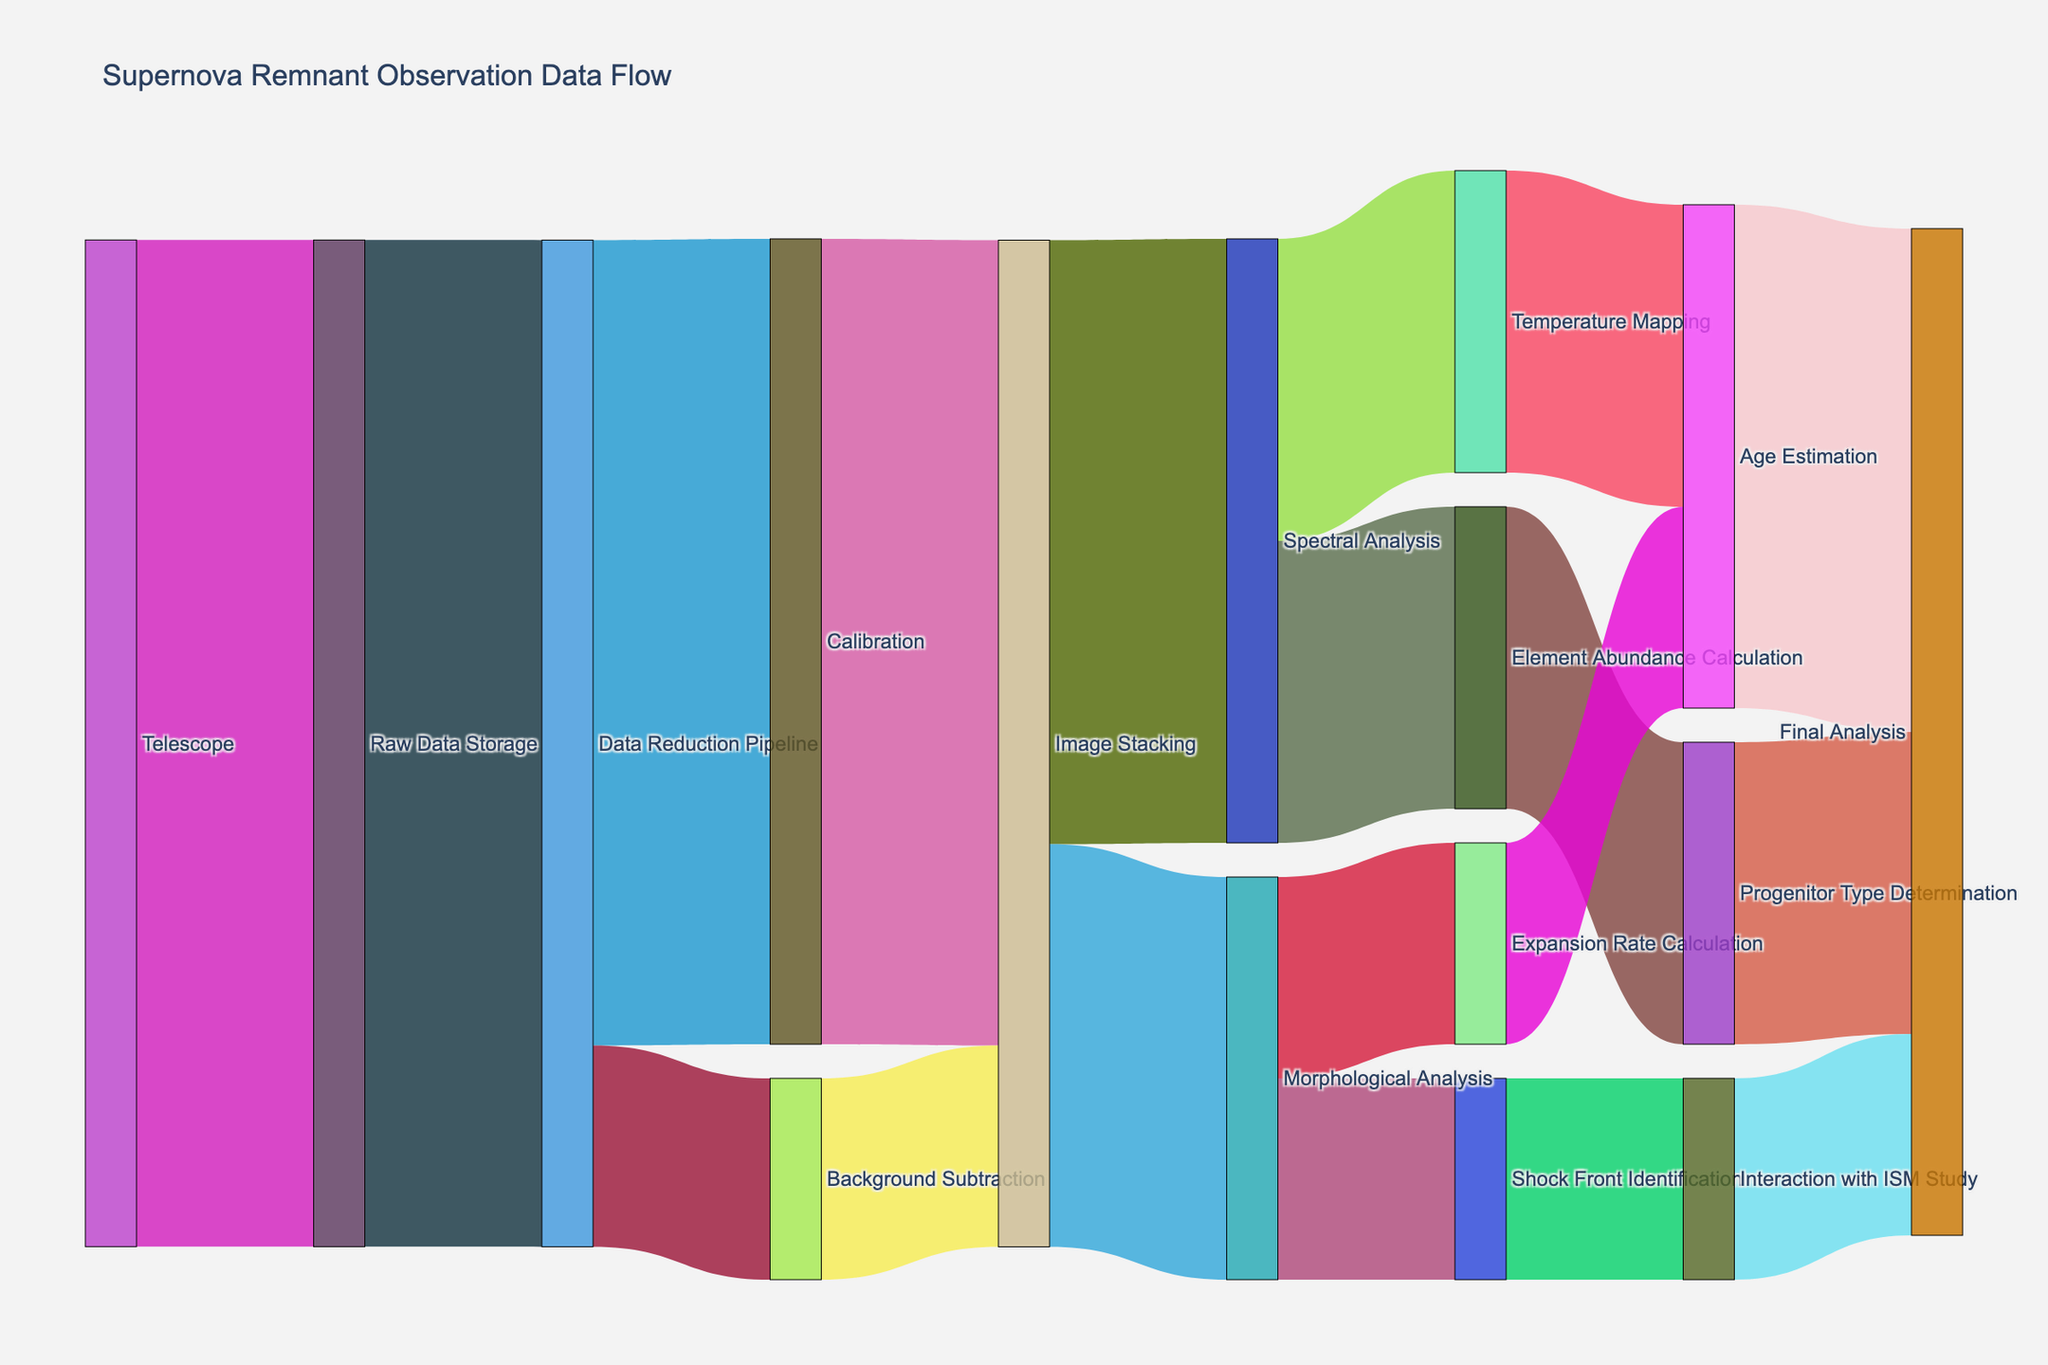Which node has the highest value coming directly from the Telescope? The diagram shows the flow of data from the Telescope node, and the node with the thickest link or highest value connected to it is Raw Data Storage, which receives 100 units of data.
Answer: Raw Data Storage What is the total value of data processed by the Data Reduction Pipeline? The Data Reduction Pipeline node sends data to Calibration (80 units) and Background Subtraction (20 units). Adding these values gives 100 units.
Answer: 100 Compare the value of data flowing into Spectral Analysis and Morphological Analysis from Image Stacking. Which one has a higher value? The Image Stacking node sends 60 units to Spectral Analysis and 40 units to Morphological Analysis. 60 units is higher than 40 units.
Answer: Spectral Analysis How much data is ultimately processed by Final Analysis? Final Analysis receives data from Progenitor Type Determination (30 units), Age Estimation (50 units), and Interaction with ISM Study (20 units). Adding these values gives 30 + 50 + 20 = 100 units.
Answer: 100 What is the total value distributed from the Calibration node? Calibration sends 80 units to Image Stacking. Since there is only one outgoing connection from Calibration, this value is the total distributed by Calibration.
Answer: 80 Which nodes receive data from Image Stacking and how much? Image Stacking sends 60 units to Spectral Analysis and 40 units to Morphological Analysis.
Answer: Spectral Analysis (60), Morphological Analysis (40) What proportion of data goes to Temperature Mapping from Spectral Analysis? Spectral Analysis distributes its 60 units of data equally between Element Abundance Calculation and Temperature Mapping, each receiving 30 units. The proportion is 30/60 = 0.5 or 50%.
Answer: 50% How does the data flow from Background Subtraction to Interaction with ISM Study? Background Subtraction sends 20 units to Image Stacking, which then splits the data into Spectral Analysis (60 units) and Morphological Analysis (40 units). Morphological Analysis then sends 20 units to Shock Front Identification, which ultimately sends these 20 units to Interaction with ISM Study.
Answer: Background Subtraction → Image Stacking → Morphological Analysis → Shock Front Identification → Interaction with ISM Study How many nodes directly contribute to the final analysis? Progenitor Type Determination, Age Estimation, and Interaction with ISM Study each send data to Final Analysis. This totals three nodes.
Answer: 3 